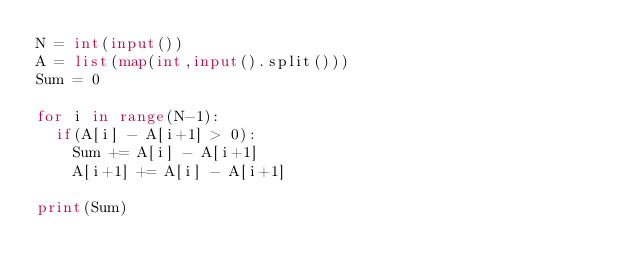<code> <loc_0><loc_0><loc_500><loc_500><_Python_>N = int(input())
A = list(map(int,input().split()))
Sum = 0

for i in range(N-1):
  if(A[i] - A[i+1] > 0):
    Sum += A[i] - A[i+1]
    A[i+1] += A[i] - A[i+1]
 
print(Sum)</code> 